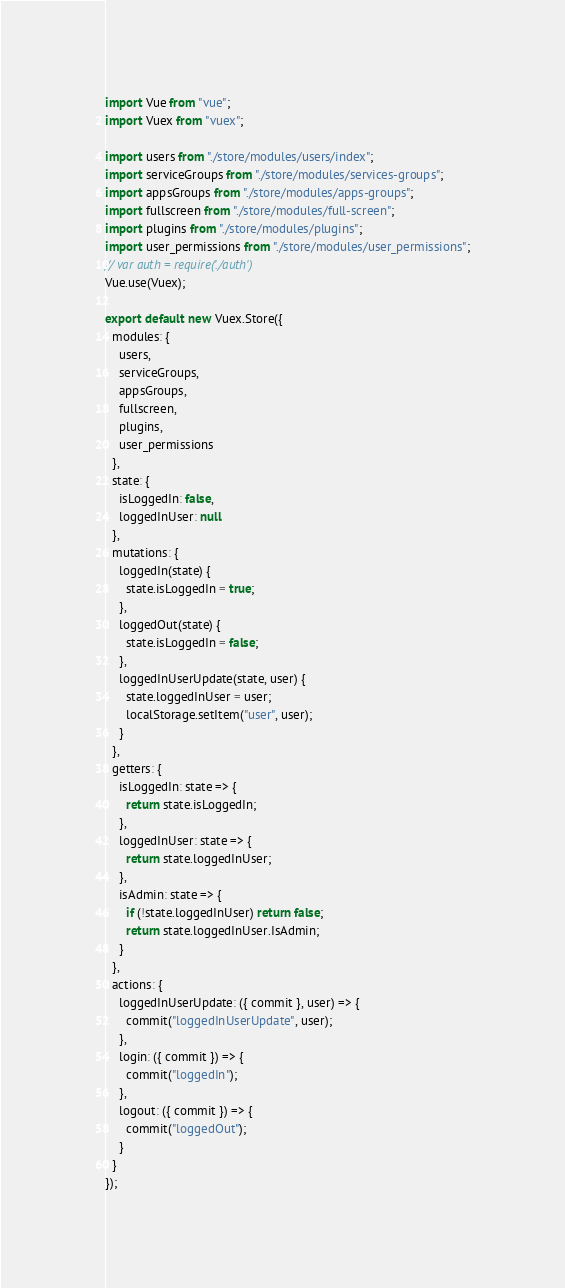<code> <loc_0><loc_0><loc_500><loc_500><_JavaScript_>import Vue from "vue";
import Vuex from "vuex";

import users from "./store/modules/users/index";
import serviceGroups from "./store/modules/services-groups";
import appsGroups from "./store/modules/apps-groups";
import fullscreen from "./store/modules/full-screen";
import plugins from "./store/modules/plugins";
import user_permissions from "./store/modules/user_permissions";
// var auth = require('./auth')
Vue.use(Vuex);

export default new Vuex.Store({
  modules: {
    users,
    serviceGroups,
    appsGroups,
    fullscreen,
    plugins,
    user_permissions
  },
  state: {
    isLoggedIn: false,
    loggedInUser: null
  },
  mutations: {
    loggedIn(state) {
      state.isLoggedIn = true;
    },
    loggedOut(state) {
      state.isLoggedIn = false;
    },
    loggedInUserUpdate(state, user) {
      state.loggedInUser = user;
      localStorage.setItem("user", user);
    }
  },
  getters: {
    isLoggedIn: state => {
      return state.isLoggedIn;
    },
    loggedInUser: state => {
      return state.loggedInUser;
    },
    isAdmin: state => {
      if (!state.loggedInUser) return false;
      return state.loggedInUser.IsAdmin;
    }
  },
  actions: {
    loggedInUserUpdate: ({ commit }, user) => {
      commit("loggedInUserUpdate", user);
    },
    login: ({ commit }) => {
      commit("loggedIn");
    },
    logout: ({ commit }) => {
      commit("loggedOut");
    }
  }
});
</code> 